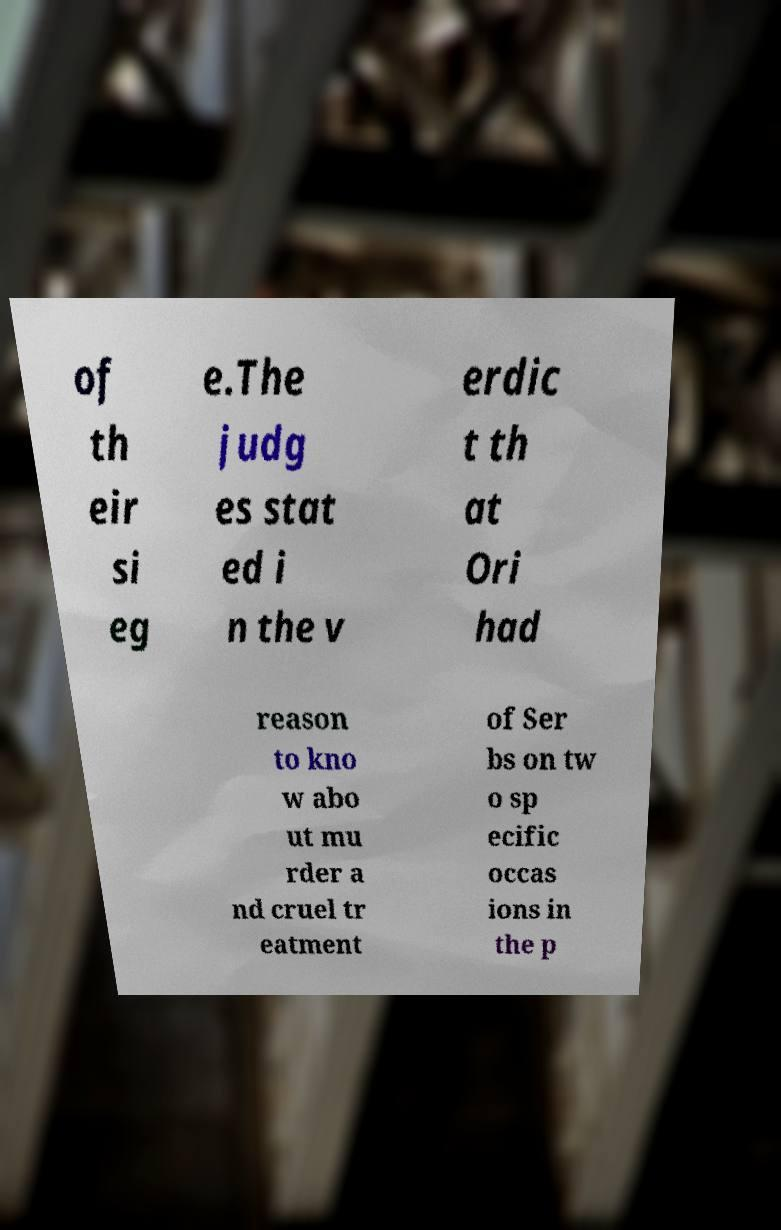Could you extract and type out the text from this image? of th eir si eg e.The judg es stat ed i n the v erdic t th at Ori had reason to kno w abo ut mu rder a nd cruel tr eatment of Ser bs on tw o sp ecific occas ions in the p 